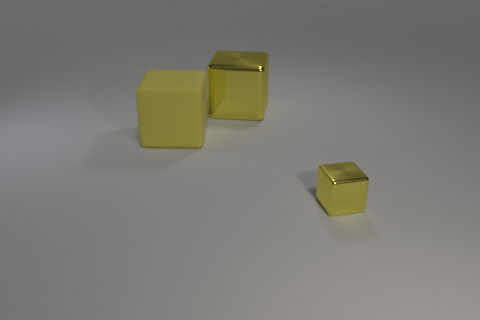Are the cubes arranged in any particular pattern? The cubes are spaced out and placed independently. Two of the cubes are upright and side by side, while the third cube is a short distance away and appears to be slightly tilted, not following a clear pattern in their arrangement. 